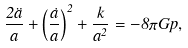<formula> <loc_0><loc_0><loc_500><loc_500>\frac { 2 \ddot { a } } { a } + \left ( \frac { \dot { a } } { a } \right ) ^ { 2 } + \frac { k } { a ^ { 2 } } = - 8 \pi G p ,</formula> 